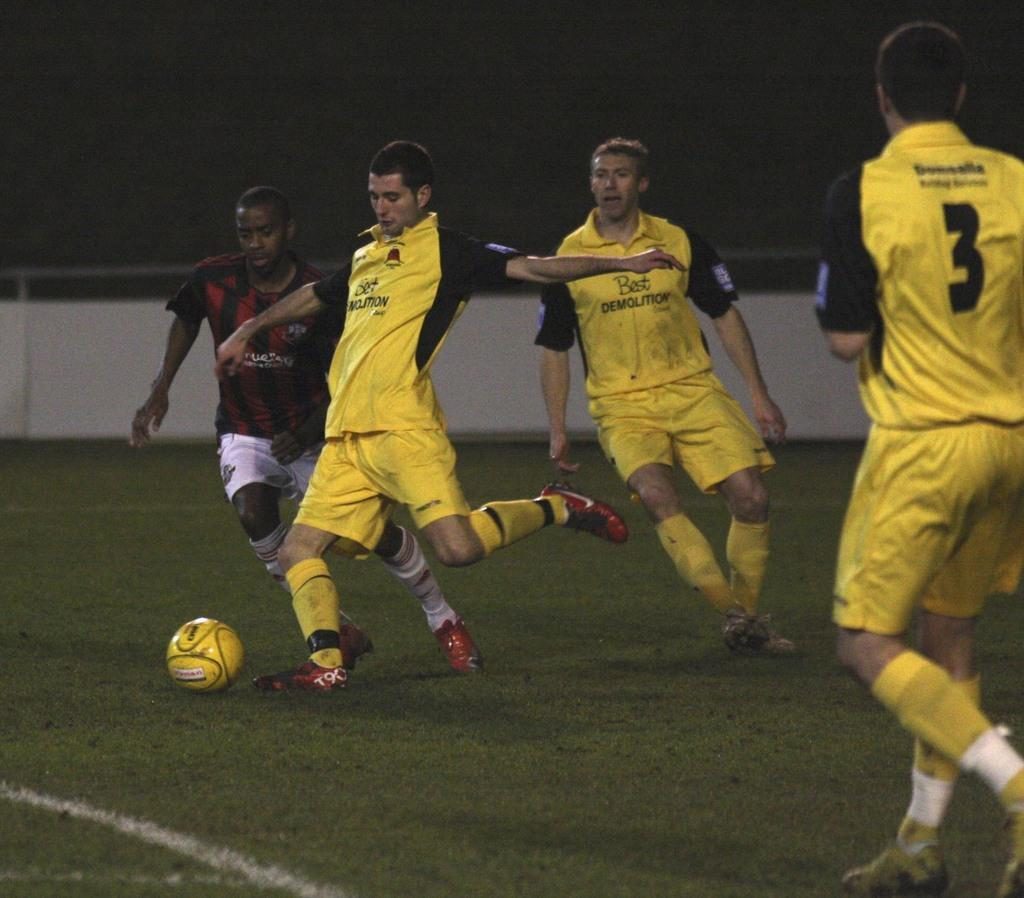<image>
Give a short and clear explanation of the subsequent image. Soccer players on a field with number 3 looking on. 